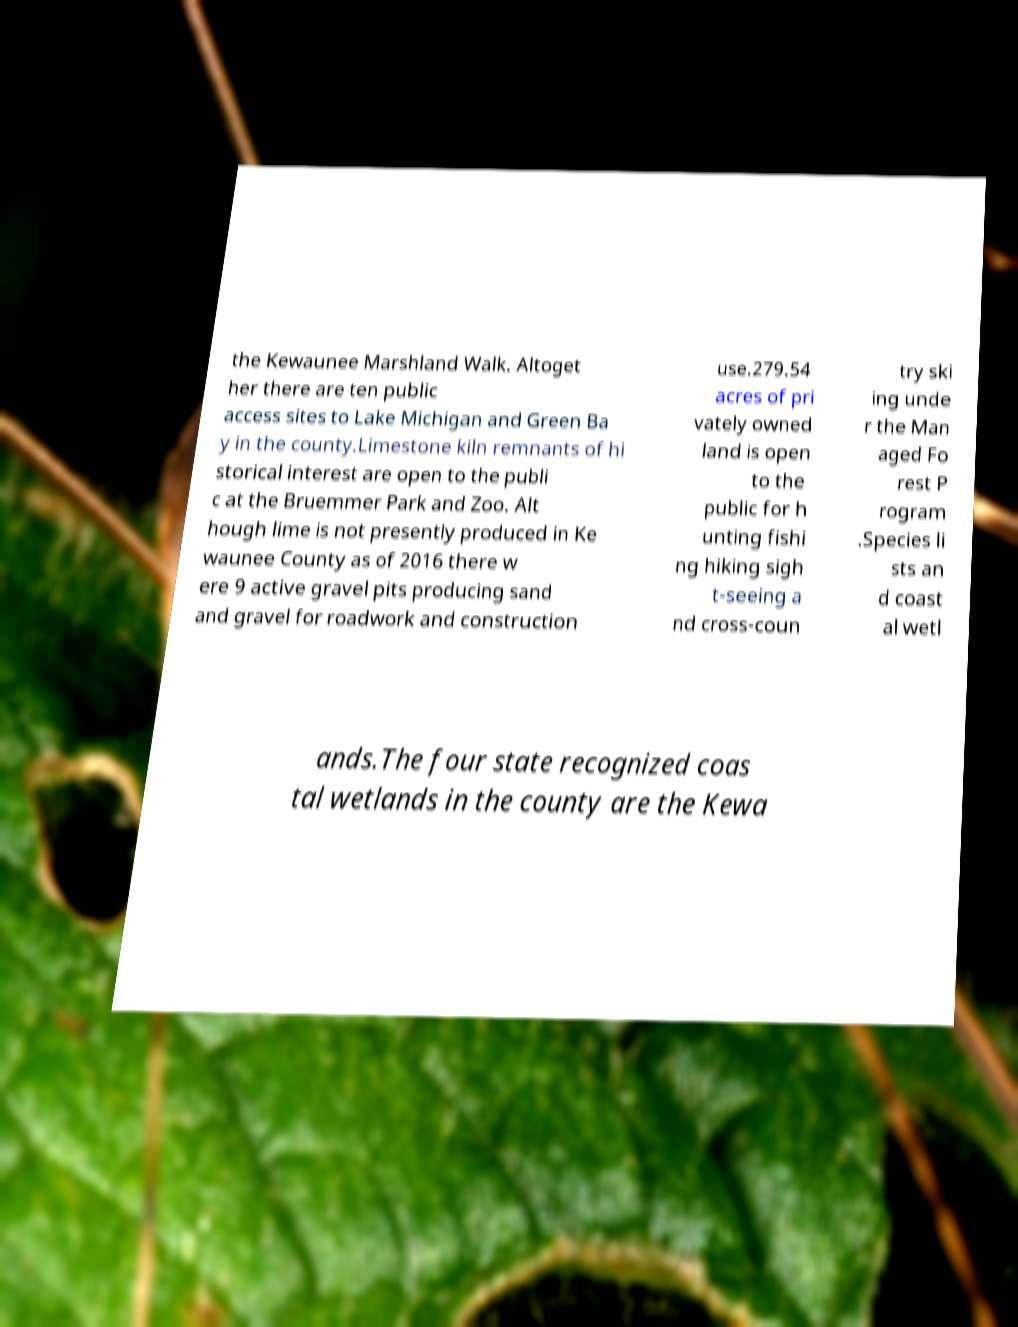Can you read and provide the text displayed in the image?This photo seems to have some interesting text. Can you extract and type it out for me? the Kewaunee Marshland Walk. Altoget her there are ten public access sites to Lake Michigan and Green Ba y in the county.Limestone kiln remnants of hi storical interest are open to the publi c at the Bruemmer Park and Zoo. Alt hough lime is not presently produced in Ke waunee County as of 2016 there w ere 9 active gravel pits producing sand and gravel for roadwork and construction use.279.54 acres of pri vately owned land is open to the public for h unting fishi ng hiking sigh t-seeing a nd cross-coun try ski ing unde r the Man aged Fo rest P rogram .Species li sts an d coast al wetl ands.The four state recognized coas tal wetlands in the county are the Kewa 